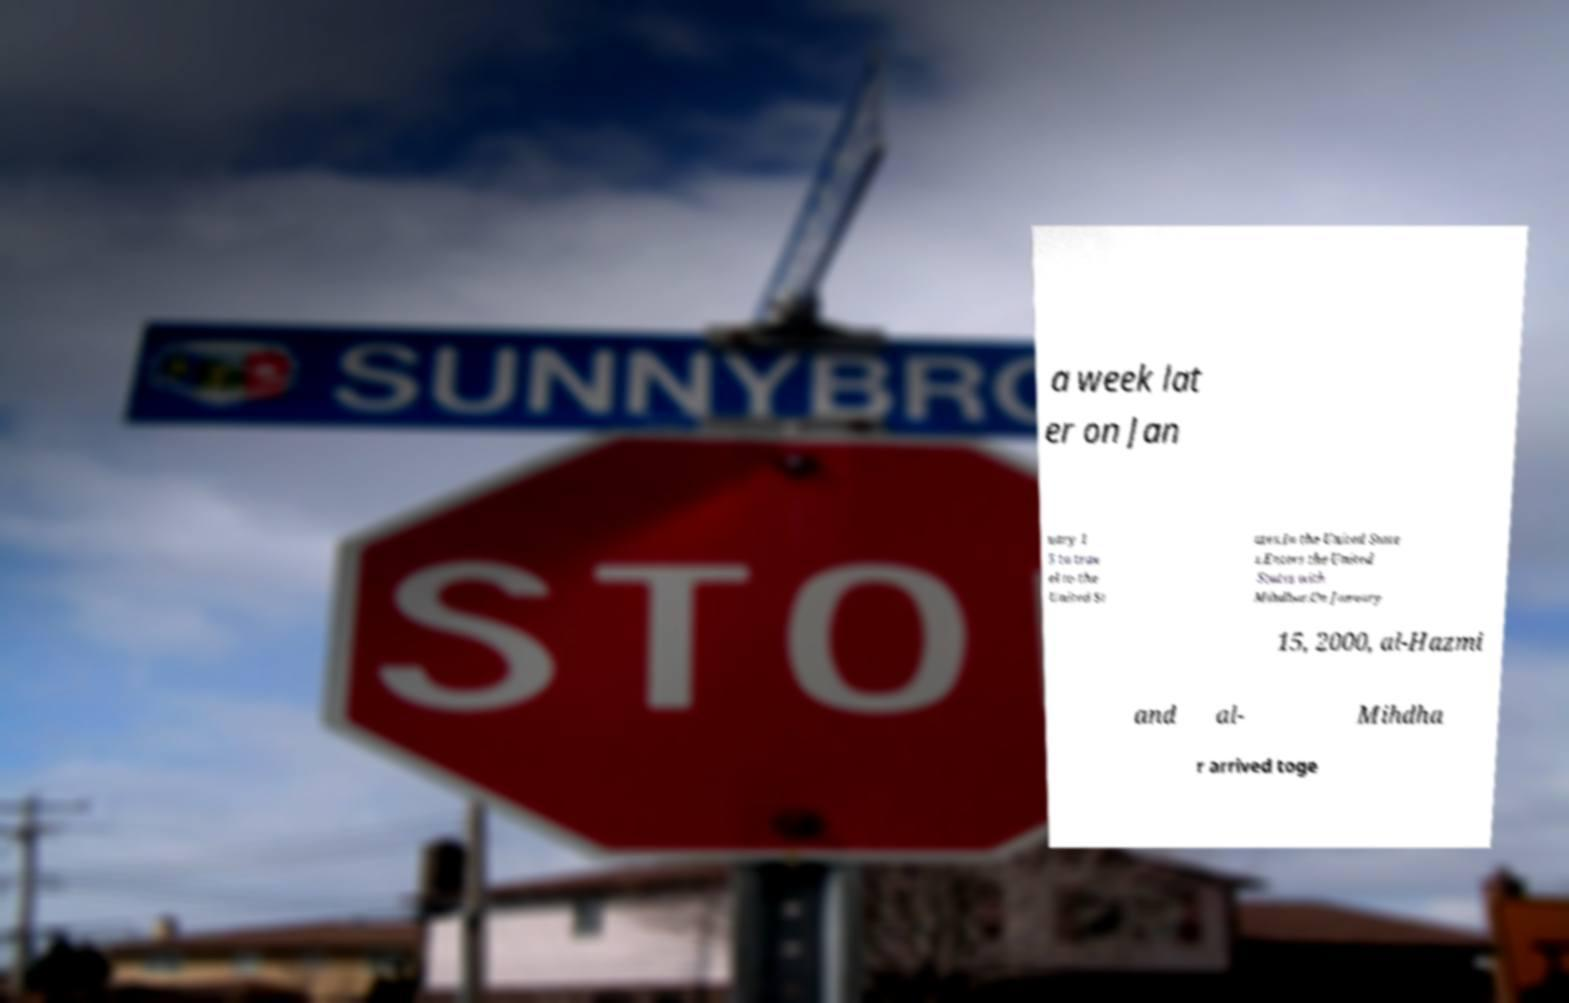There's text embedded in this image that I need extracted. Can you transcribe it verbatim? a week lat er on Jan uary 1 5 to trav el to the United St ates.In the United State s.Enters the United States with Mihdhar.On January 15, 2000, al-Hazmi and al- Mihdha r arrived toge 